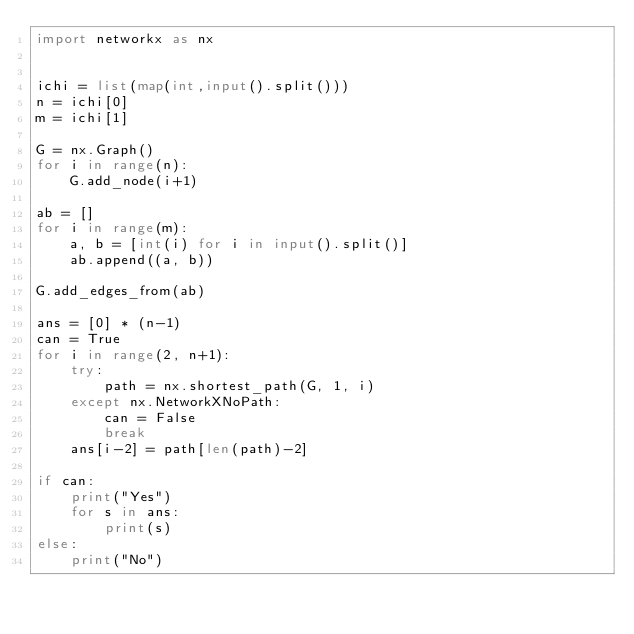Convert code to text. <code><loc_0><loc_0><loc_500><loc_500><_Python_>import networkx as nx


ichi = list(map(int,input().split()))
n = ichi[0]
m = ichi[1]

G = nx.Graph()
for i in range(n):
    G.add_node(i+1)

ab = []
for i in range(m):
    a, b = [int(i) for i in input().split()]
    ab.append((a, b))

G.add_edges_from(ab)

ans = [0] * (n-1)
can = True
for i in range(2, n+1):
    try:
        path = nx.shortest_path(G, 1, i)
    except nx.NetworkXNoPath:
        can = False
        break
    ans[i-2] = path[len(path)-2]

if can:
    print("Yes")
    for s in ans:
        print(s)
else:
    print("No")
</code> 